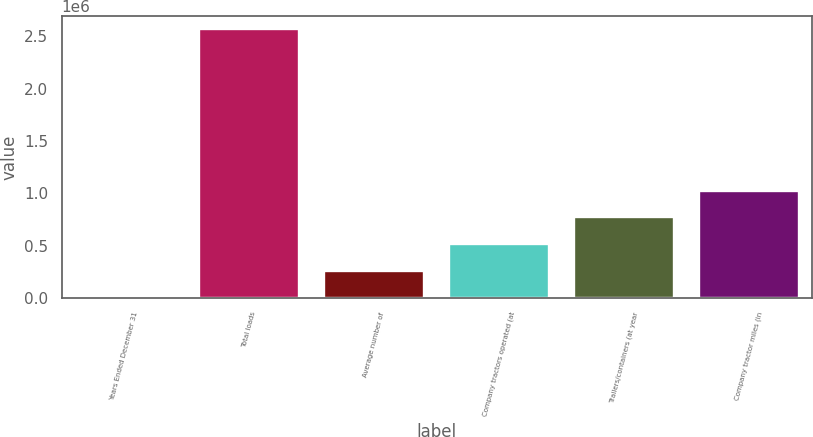Convert chart. <chart><loc_0><loc_0><loc_500><loc_500><bar_chart><fcel>Years Ended December 31<fcel>Total loads<fcel>Average number of<fcel>Company tractors operated (at<fcel>Trailers/containers (at year<fcel>Company tractor miles (in<nl><fcel>2001<fcel>2.56592e+06<fcel>258392<fcel>514784<fcel>771175<fcel>1.02757e+06<nl></chart> 